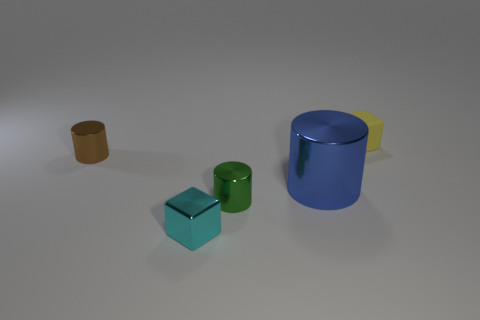There is a small cylinder on the left side of the cube in front of the object that is on the right side of the blue shiny cylinder; what is its color?
Keep it short and to the point. Brown. Are there an equal number of yellow rubber blocks right of the small green thing and small green rubber things?
Your response must be concise. No. Does the cube that is behind the brown metallic cylinder have the same size as the green cylinder?
Your answer should be compact. Yes. How many metallic cubes are there?
Provide a short and direct response. 1. How many small objects are both behind the tiny cyan object and to the left of the small green thing?
Offer a very short reply. 1. Are there any other tiny cylinders made of the same material as the green cylinder?
Provide a short and direct response. Yes. The tiny object behind the brown object that is behind the tiny cyan metal cube is made of what material?
Give a very brief answer. Rubber. Are there the same number of tiny yellow matte objects that are on the left side of the large blue metallic cylinder and objects behind the small green metal cylinder?
Offer a very short reply. No. Does the green shiny thing have the same shape as the brown metal thing?
Your response must be concise. Yes. There is a small thing that is to the right of the tiny shiny cube and in front of the big blue thing; what material is it made of?
Keep it short and to the point. Metal. 